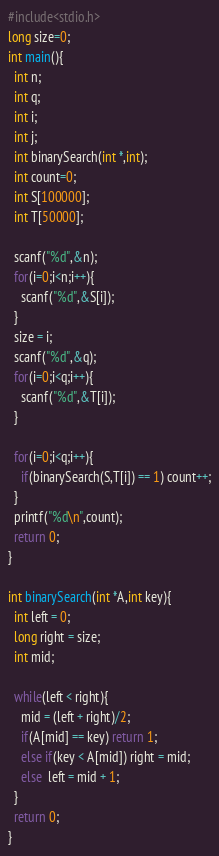Convert code to text. <code><loc_0><loc_0><loc_500><loc_500><_C_>#include<stdio.h>
long size=0;
int main(){
  int n;
  int q;
  int i;
  int j;
  int binarySearch(int *,int);
  int count=0;
  int S[100000];
  int T[50000];

  scanf("%d",&n);  
  for(i=0;i<n;i++){
    scanf("%d",&S[i]);
  }
  size = i;
  scanf("%d",&q);
  for(i=0;i<q;i++){
    scanf("%d",&T[i]);
  }

  for(i=0;i<q;i++){
    if(binarySearch(S,T[i]) == 1) count++;
  }
  printf("%d\n",count);
  return 0;
}

int binarySearch(int *A,int key){
  int left = 0;
  long right = size;
  int mid;
  
  while(left < right){
    mid = (left + right)/2;
    if(A[mid] == key) return 1;
    else if(key < A[mid]) right = mid;
    else  left = mid + 1;
  }
  return 0;
}

</code> 